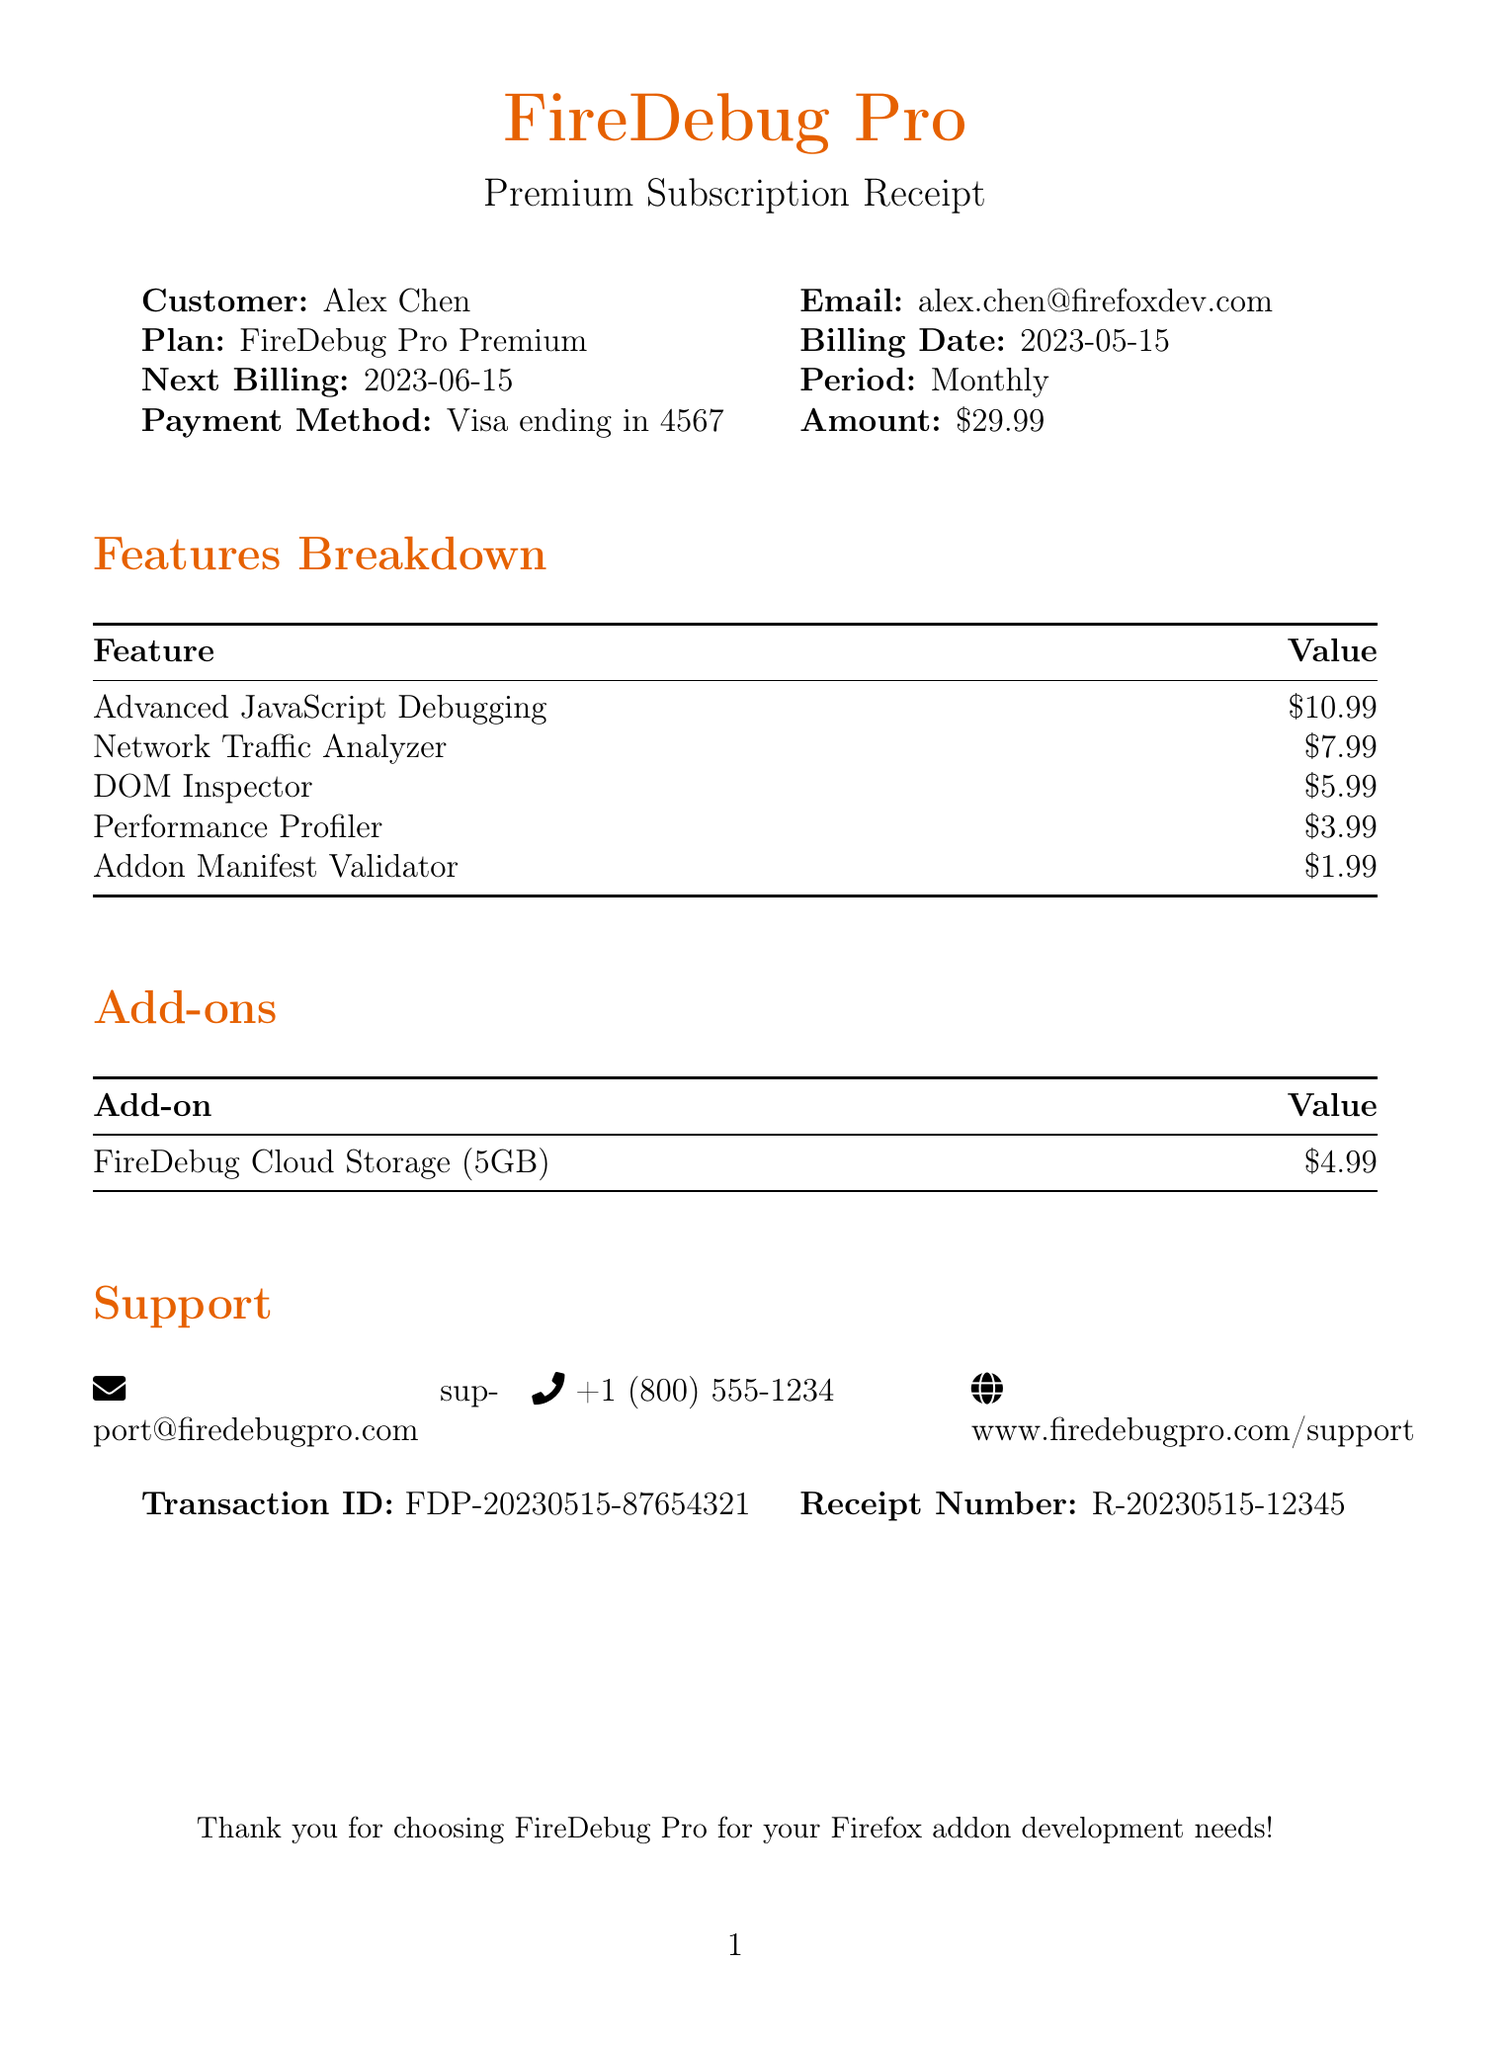What is the company name? The company is FireDebug Pro, as stated at the top of the receipt.
Answer: FireDebug Pro Who is the customer? The document specifies the customer's name as Alex Chen.
Answer: Alex Chen What is the subscription amount? The subscription amount is listed clearly in the receipt as $29.99.
Answer: $29.99 When is the next billing date? The next billing date is indicated on the receipt and is shown as 2023-06-15.
Answer: 2023-06-15 How many features are included in the subscription? There are five features listed under the features breakdown in the document.
Answer: Five What value is assigned to the "Network Traffic Analyzer" feature? The value for this feature is clearly stated in the features section as $7.99.
Answer: $7.99 What is the length of cloud storage provided with the add-on? The add-on provides 5GB of cloud storage, as mentioned in the document.
Answer: 5GB What is the Transaction ID? The Transaction ID is specified in the document as FDP-20230515-87654321.
Answer: FDP-20230515-87654321 What payment method is used for the subscription? The payment method is indicated as Visa ending in 4567.
Answer: Visa ending in 4567 